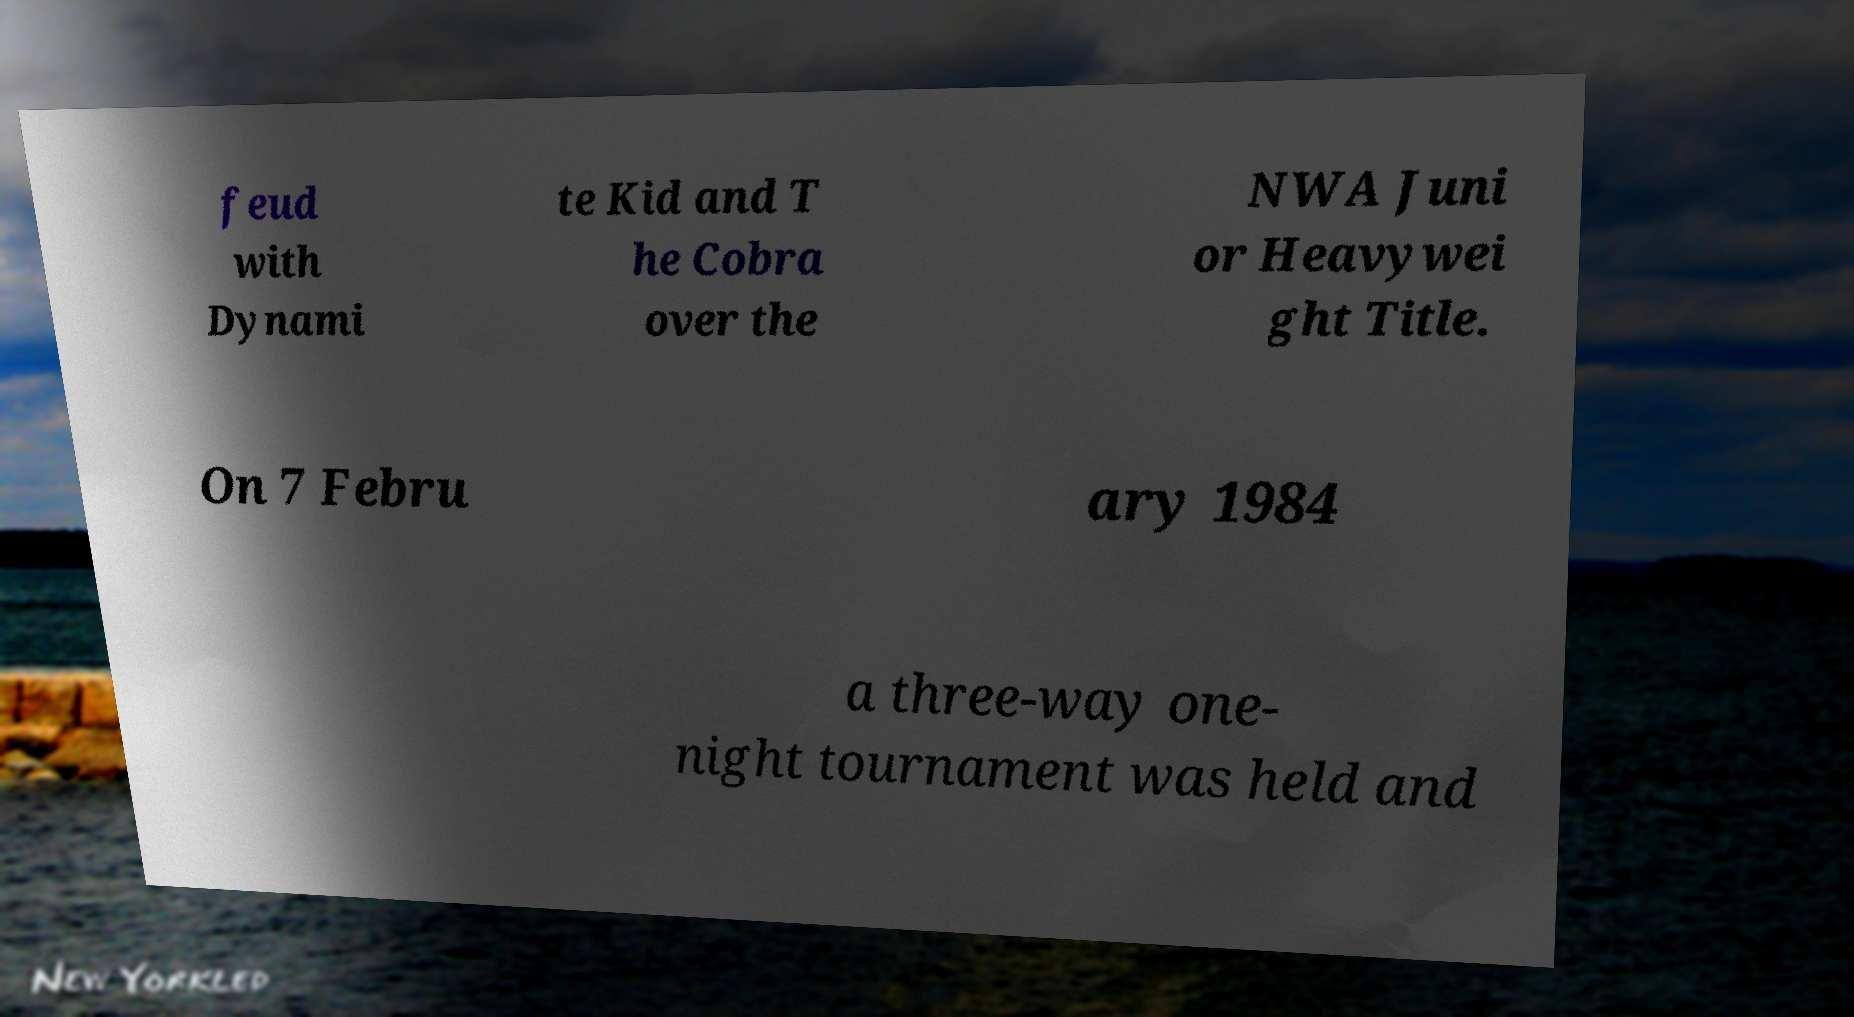Please read and relay the text visible in this image. What does it say? feud with Dynami te Kid and T he Cobra over the NWA Juni or Heavywei ght Title. On 7 Febru ary 1984 a three-way one- night tournament was held and 